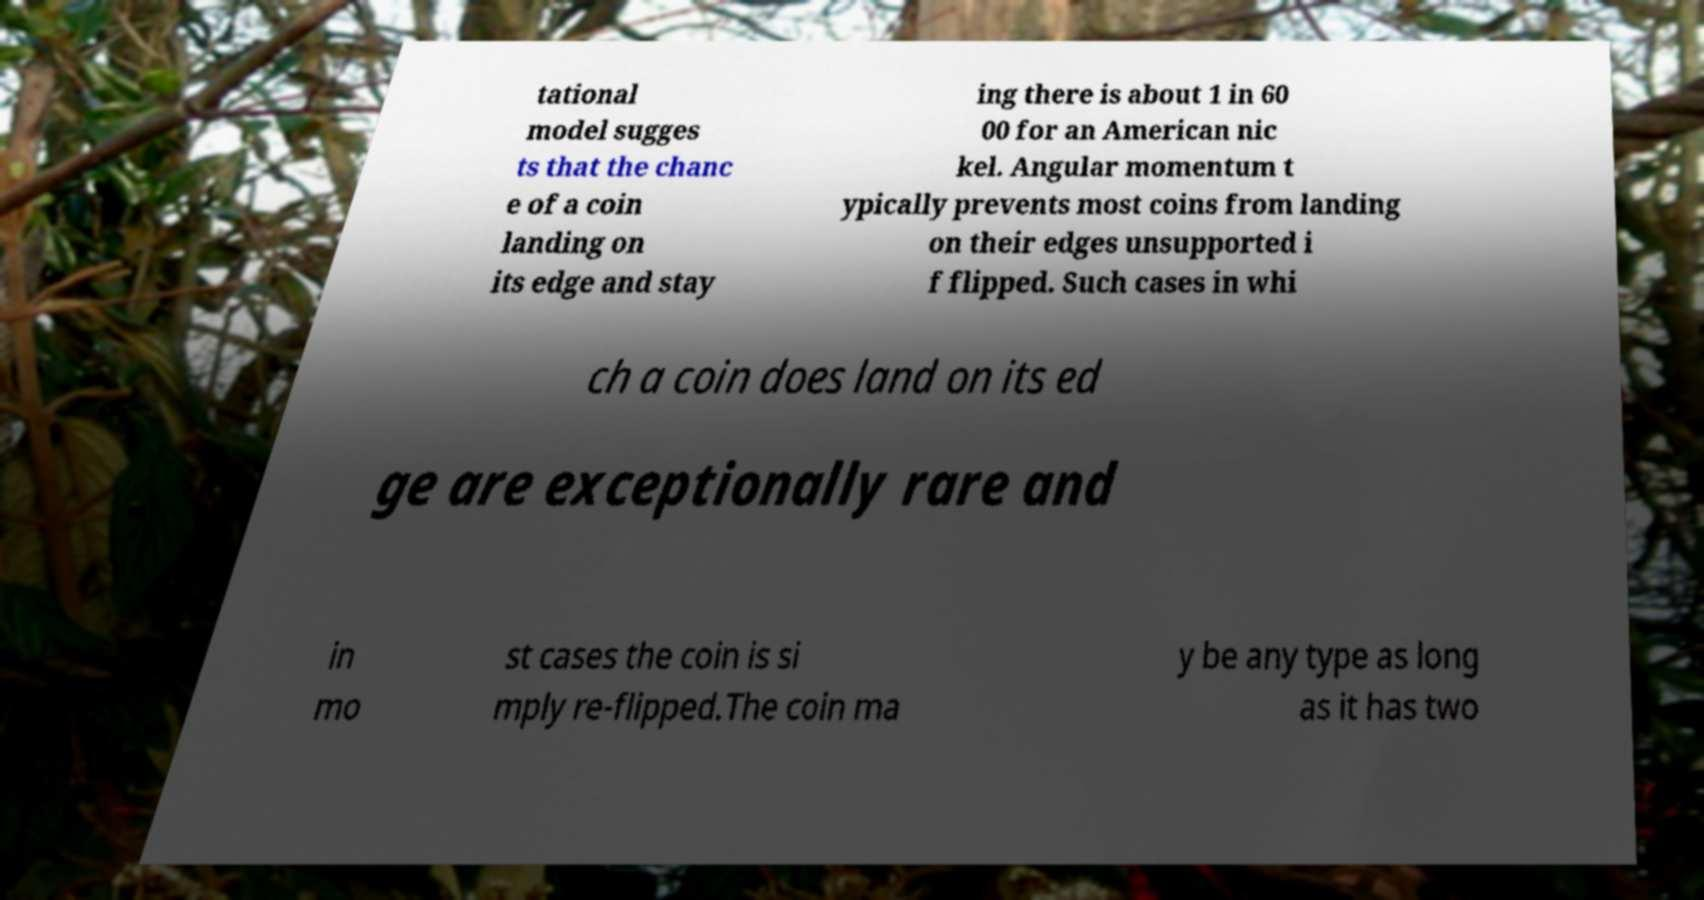Please read and relay the text visible in this image. What does it say? tational model sugges ts that the chanc e of a coin landing on its edge and stay ing there is about 1 in 60 00 for an American nic kel. Angular momentum t ypically prevents most coins from landing on their edges unsupported i f flipped. Such cases in whi ch a coin does land on its ed ge are exceptionally rare and in mo st cases the coin is si mply re-flipped.The coin ma y be any type as long as it has two 